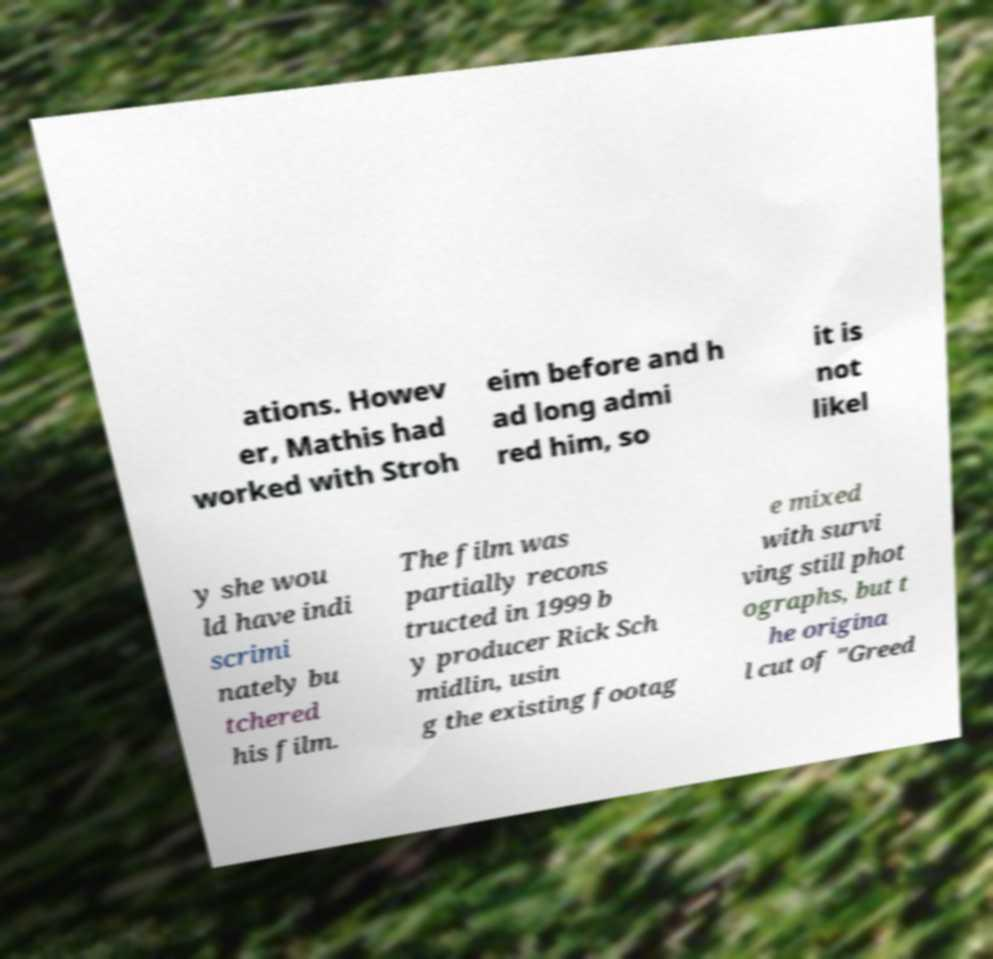What messages or text are displayed in this image? I need them in a readable, typed format. ations. Howev er, Mathis had worked with Stroh eim before and h ad long admi red him, so it is not likel y she wou ld have indi scrimi nately bu tchered his film. The film was partially recons tructed in 1999 b y producer Rick Sch midlin, usin g the existing footag e mixed with survi ving still phot ographs, but t he origina l cut of "Greed 